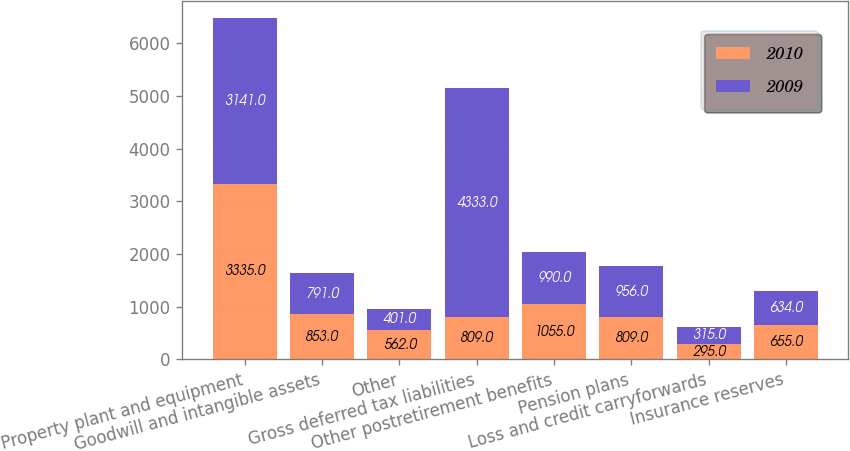Convert chart. <chart><loc_0><loc_0><loc_500><loc_500><stacked_bar_chart><ecel><fcel>Property plant and equipment<fcel>Goodwill and intangible assets<fcel>Other<fcel>Gross deferred tax liabilities<fcel>Other postretirement benefits<fcel>Pension plans<fcel>Loss and credit carryforwards<fcel>Insurance reserves<nl><fcel>2010<fcel>3335<fcel>853<fcel>562<fcel>809<fcel>1055<fcel>809<fcel>295<fcel>655<nl><fcel>2009<fcel>3141<fcel>791<fcel>401<fcel>4333<fcel>990<fcel>956<fcel>315<fcel>634<nl></chart> 